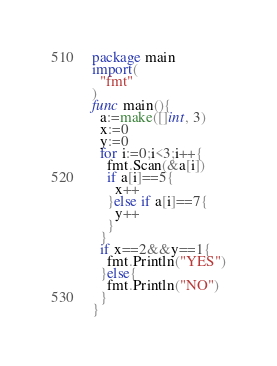Convert code to text. <code><loc_0><loc_0><loc_500><loc_500><_Go_>package main
import(
  "fmt"
)
func main(){
  a:=make([]int, 3)
  x:=0
  y:=0
  for i:=0;i<3;i++{
    fmt.Scan(&a[i])
    if a[i]==5{
      x++
    }else if a[i]==7{
      y++
    }
  }
  if x==2&&y==1{
    fmt.Println("YES")
  }else{
    fmt.Println("NO")
  }
}
</code> 